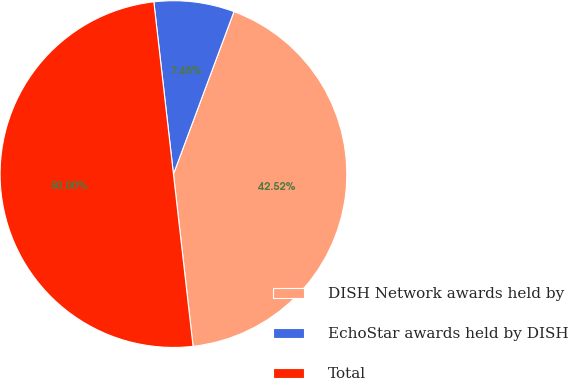Convert chart. <chart><loc_0><loc_0><loc_500><loc_500><pie_chart><fcel>DISH Network awards held by<fcel>EchoStar awards held by DISH<fcel>Total<nl><fcel>42.52%<fcel>7.48%<fcel>50.0%<nl></chart> 